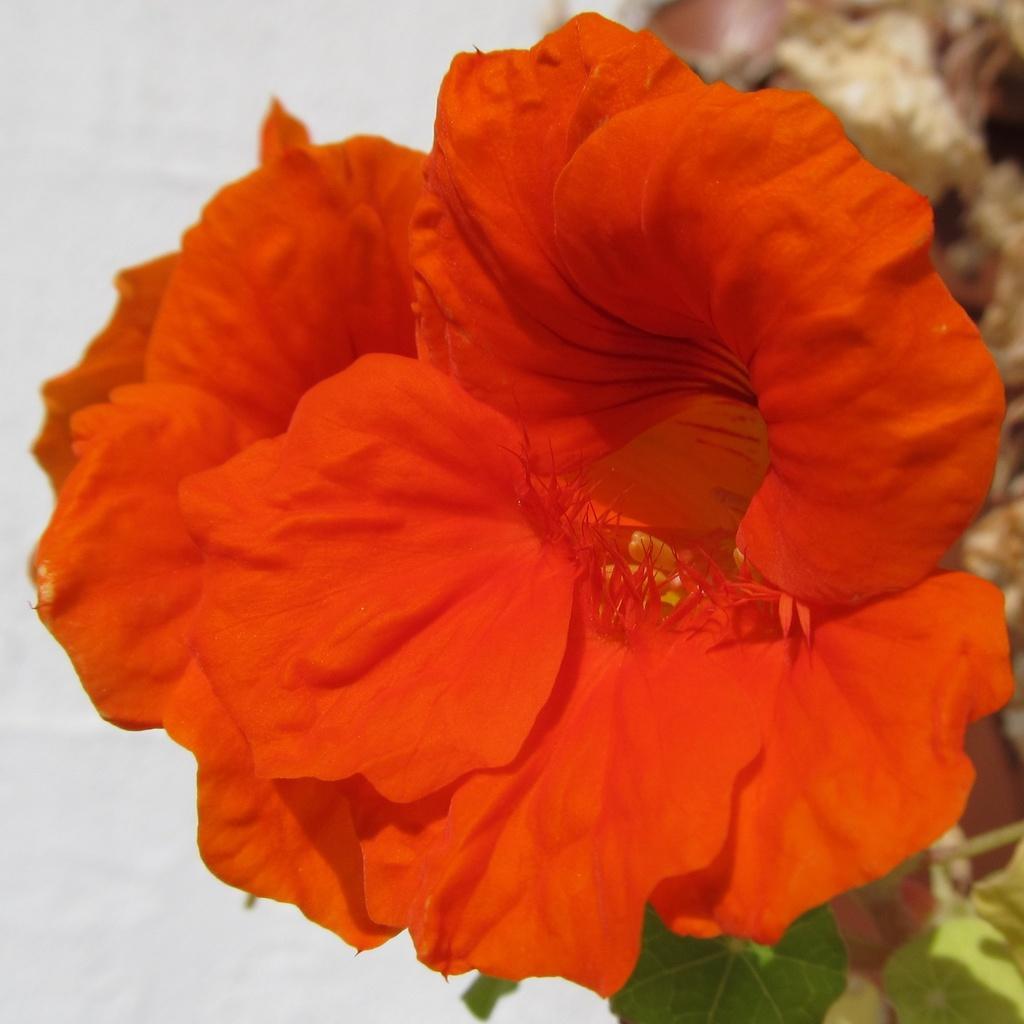How would you summarize this image in a sentence or two? In this image, we can see flowers and leaves. Background we can see the white color. 